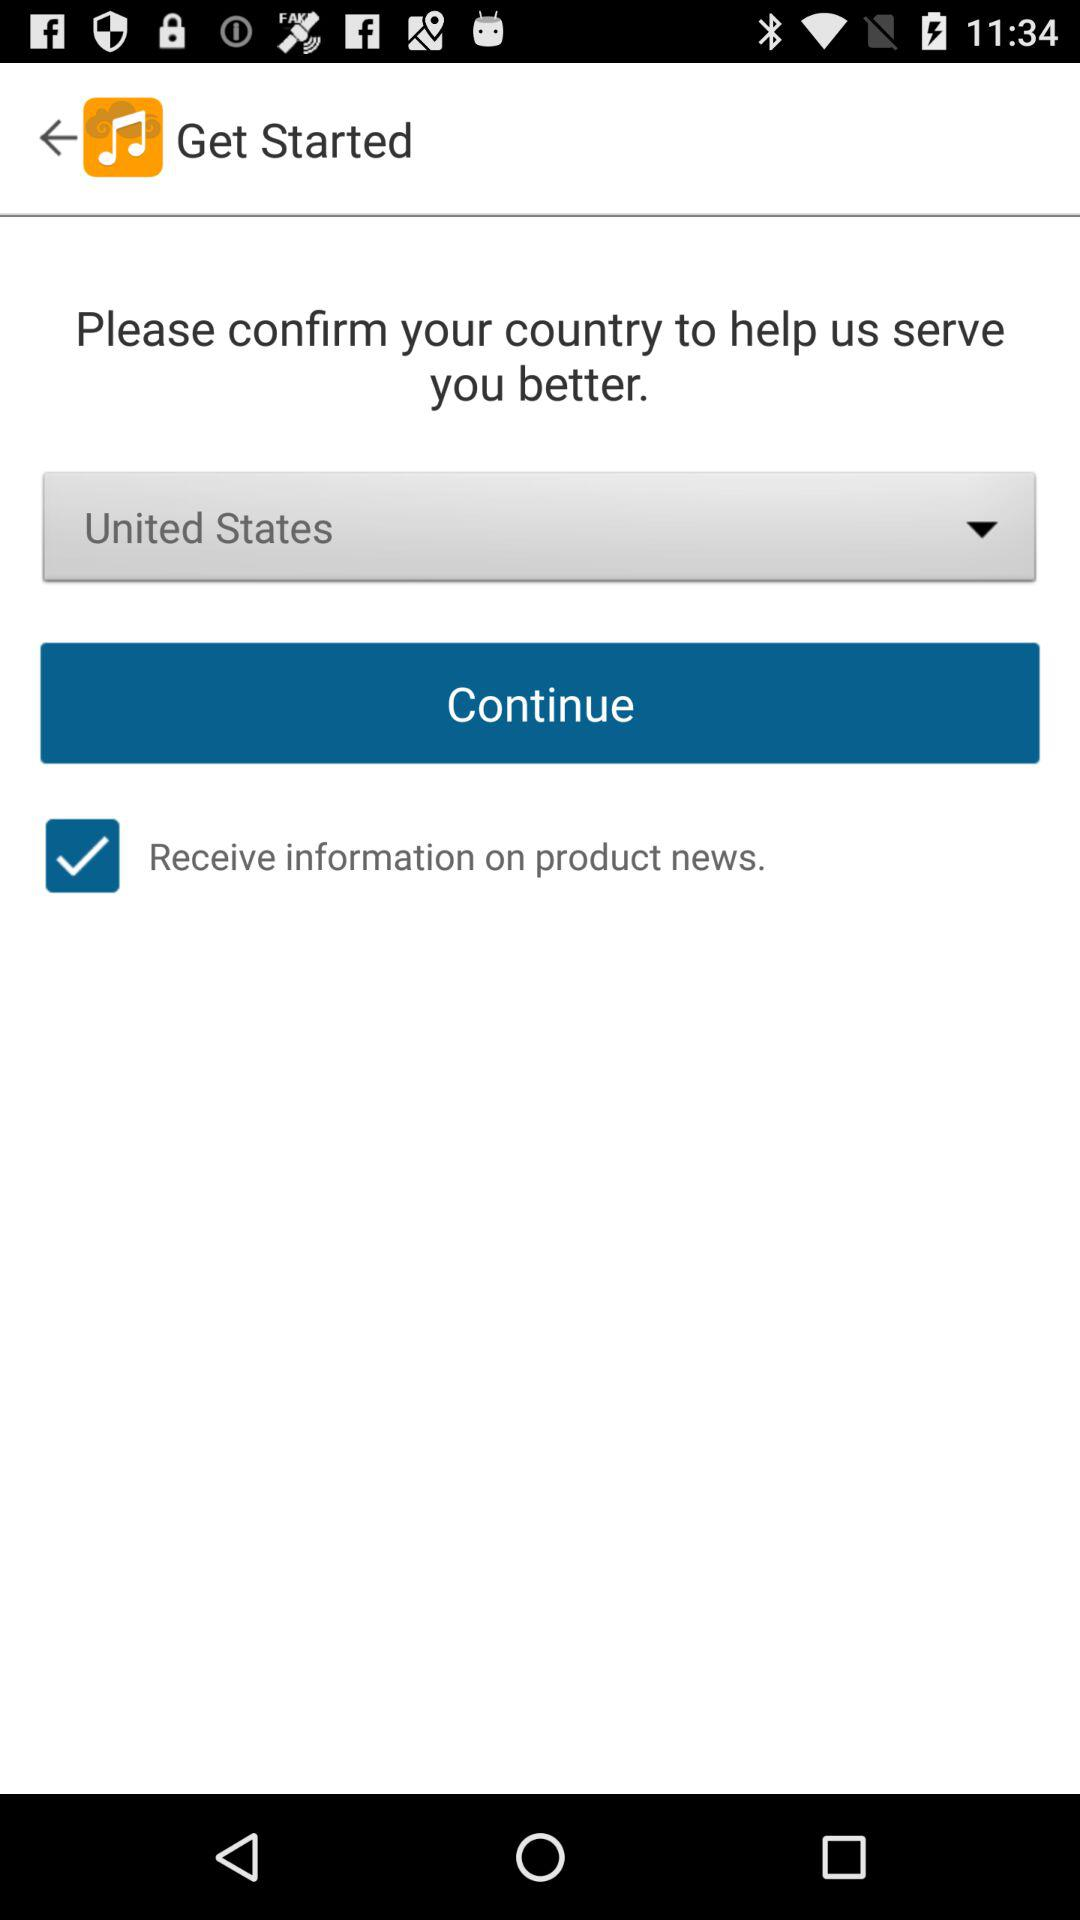Which is the selected country? The selected country is the United States. 